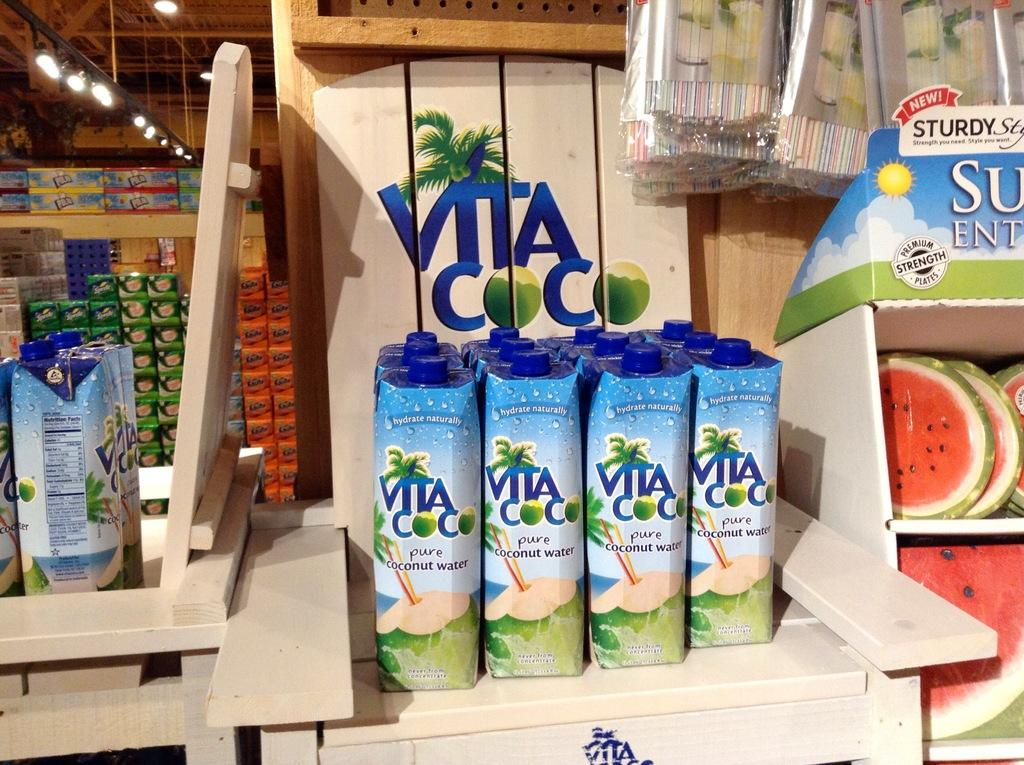<image>
Render a clear and concise summary of the photo. Several containers of Vita Coco are on display. 